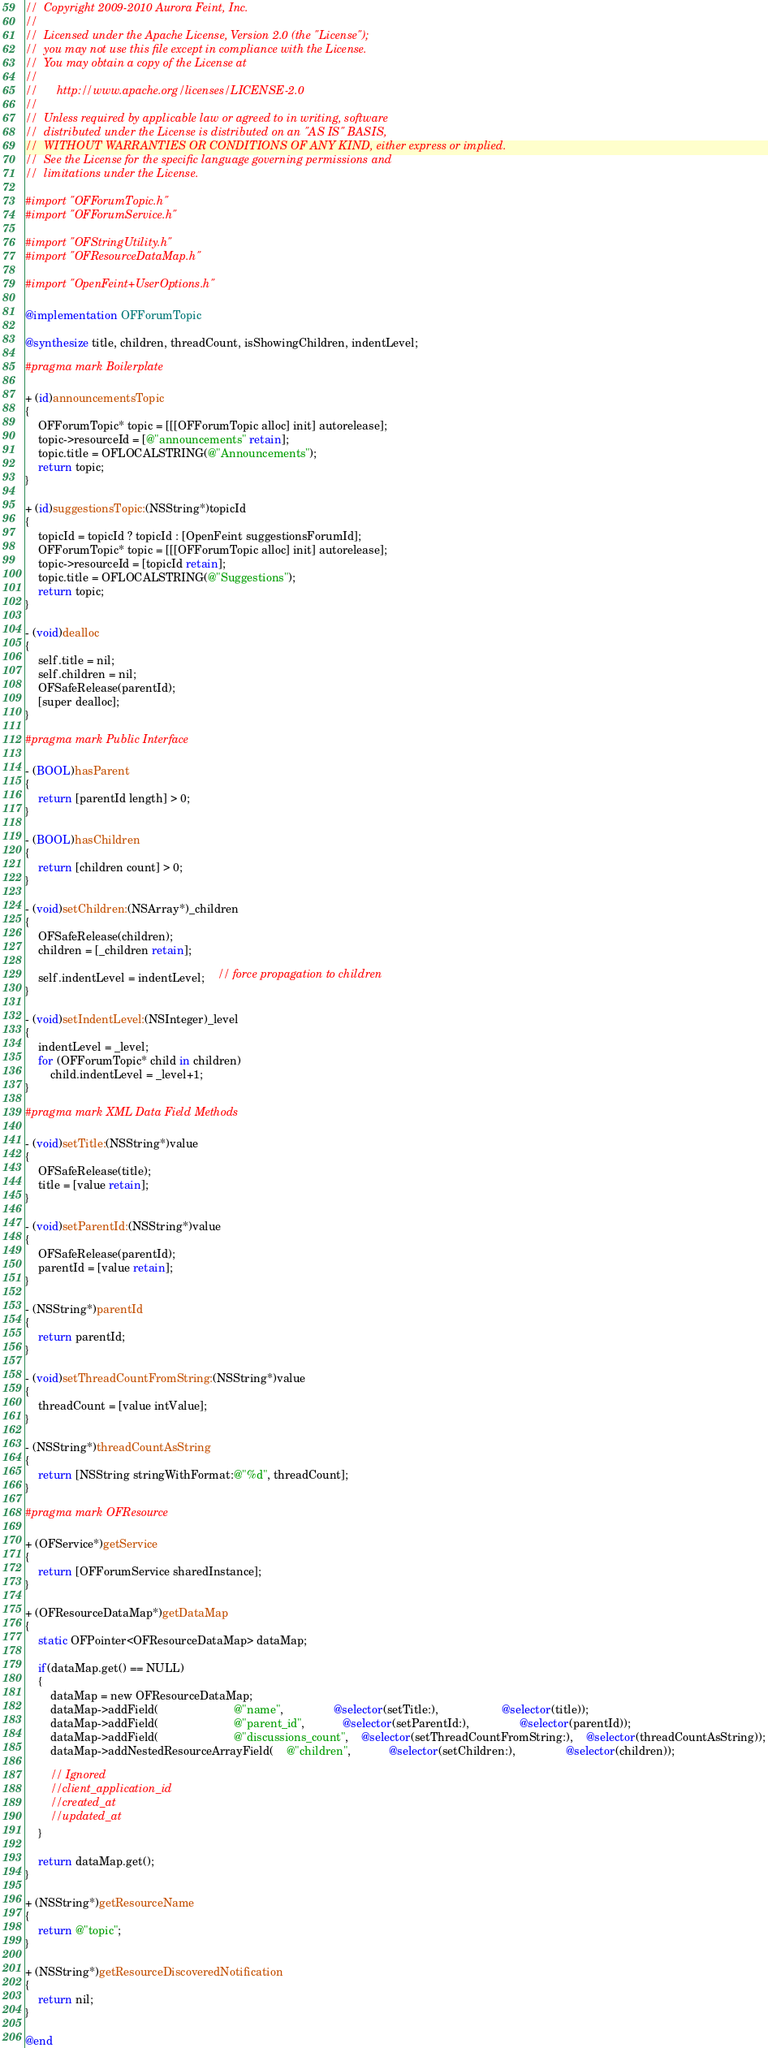Convert code to text. <code><loc_0><loc_0><loc_500><loc_500><_ObjectiveC_>//  Copyright 2009-2010 Aurora Feint, Inc.
// 
//  Licensed under the Apache License, Version 2.0 (the "License");
//  you may not use this file except in compliance with the License.
//  You may obtain a copy of the License at
//  
//  	http://www.apache.org/licenses/LICENSE-2.0
//  	
//  Unless required by applicable law or agreed to in writing, software
//  distributed under the License is distributed on an "AS IS" BASIS,
//  WITHOUT WARRANTIES OR CONDITIONS OF ANY KIND, either express or implied.
//  See the License for the specific language governing permissions and
//  limitations under the License.

#import "OFForumTopic.h"
#import "OFForumService.h"

#import "OFStringUtility.h"
#import "OFResourceDataMap.h"

#import "OpenFeint+UserOptions.h"

@implementation OFForumTopic

@synthesize title, children, threadCount, isShowingChildren, indentLevel;

#pragma mark Boilerplate

+ (id)announcementsTopic
{
	OFForumTopic* topic = [[[OFForumTopic alloc] init] autorelease];
	topic->resourceId = [@"announcements" retain];
	topic.title = OFLOCALSTRING(@"Announcements");
	return topic;	
}

+ (id)suggestionsTopic:(NSString*)topicId
{
	topicId = topicId ? topicId : [OpenFeint suggestionsForumId];
	OFForumTopic* topic = [[[OFForumTopic alloc] init] autorelease];
	topic->resourceId = [topicId retain];
	topic.title = OFLOCALSTRING(@"Suggestions");
	return topic;	
}

- (void)dealloc
{
	self.title = nil;
	self.children = nil;
	OFSafeRelease(parentId);
	[super dealloc];
}

#pragma mark Public Interface

- (BOOL)hasParent
{
	return [parentId length] > 0;
}

- (BOOL)hasChildren
{
	return [children count] > 0;
}

- (void)setChildren:(NSArray*)_children
{
	OFSafeRelease(children);
	children = [_children retain];

	self.indentLevel = indentLevel;	// force propagation to children
}

- (void)setIndentLevel:(NSInteger)_level
{
	indentLevel = _level;
	for (OFForumTopic* child in children)
		child.indentLevel = _level+1;
}

#pragma mark XML Data Field Methods

- (void)setTitle:(NSString*)value
{
	OFSafeRelease(title);
	title = [value retain];
}

- (void)setParentId:(NSString*)value
{
	OFSafeRelease(parentId);
	parentId = [value retain];
}

- (NSString*)parentId
{
	return parentId;
}

- (void)setThreadCountFromString:(NSString*)value
{
	threadCount = [value intValue];
}

- (NSString*)threadCountAsString
{
	return [NSString stringWithFormat:@"%d", threadCount];
}

#pragma mark OFResource

+ (OFService*)getService
{
	return [OFForumService sharedInstance];
}

+ (OFResourceDataMap*)getDataMap
{
	static OFPointer<OFResourceDataMap> dataMap;
	
	if(dataMap.get() == NULL)
	{
		dataMap = new OFResourceDataMap;
		dataMap->addField(						@"name",				@selector(setTitle:),					@selector(title));
		dataMap->addField(						@"parent_id",			@selector(setParentId:),				@selector(parentId));
		dataMap->addField(						@"discussions_count",	@selector(setThreadCountFromString:),	@selector(threadCountAsString));
		dataMap->addNestedResourceArrayField(	@"children",			@selector(setChildren:),				@selector(children));
		
		// Ignored
		//client_application_id
		//created_at
		//updated_at
	}
	
	return dataMap.get();
}

+ (NSString*)getResourceName
{
	return @"topic";
}

+ (NSString*)getResourceDiscoveredNotification
{
	return nil;
}

@end
</code> 